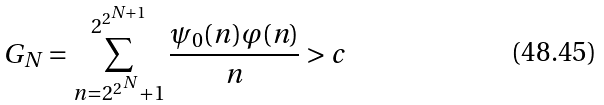Convert formula to latex. <formula><loc_0><loc_0><loc_500><loc_500>G _ { N } = \sum _ { n = 2 ^ { 2 ^ { N } } + 1 } ^ { 2 ^ { 2 ^ { N + 1 } } } \frac { \psi _ { 0 } ( n ) \varphi ( n ) } { n } > c</formula> 